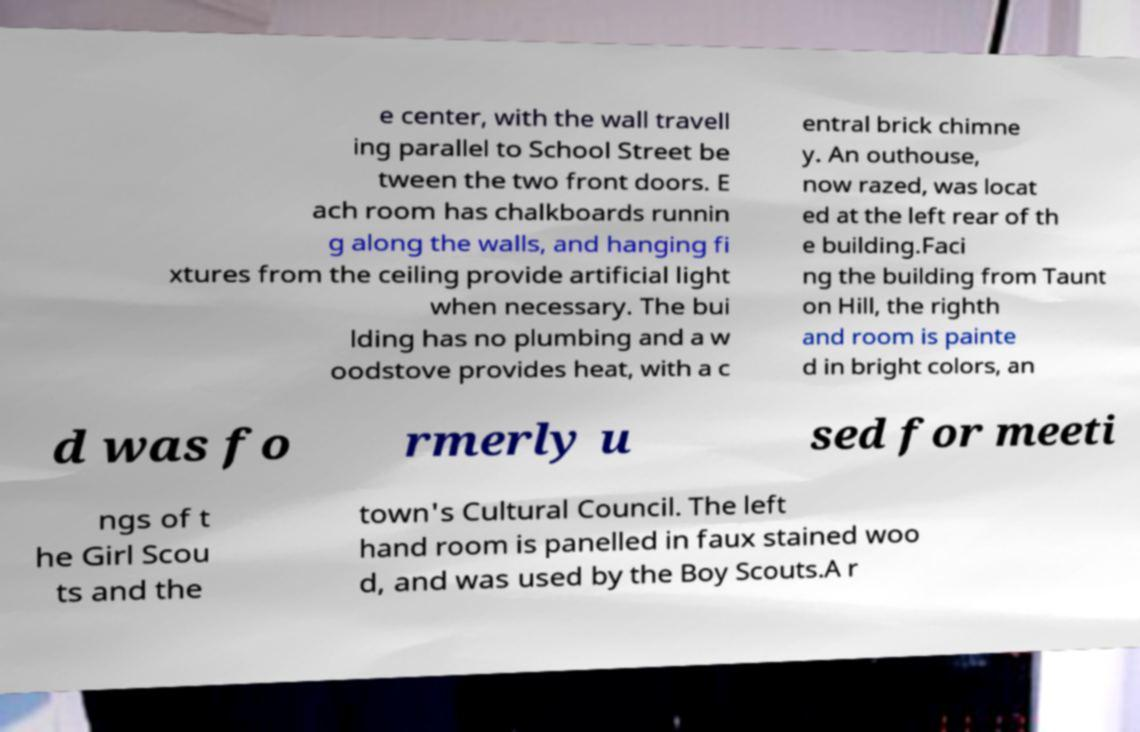Could you assist in decoding the text presented in this image and type it out clearly? e center, with the wall travell ing parallel to School Street be tween the two front doors. E ach room has chalkboards runnin g along the walls, and hanging fi xtures from the ceiling provide artificial light when necessary. The bui lding has no plumbing and a w oodstove provides heat, with a c entral brick chimne y. An outhouse, now razed, was locat ed at the left rear of th e building.Faci ng the building from Taunt on Hill, the righth and room is painte d in bright colors, an d was fo rmerly u sed for meeti ngs of t he Girl Scou ts and the town's Cultural Council. The left hand room is panelled in faux stained woo d, and was used by the Boy Scouts.A r 